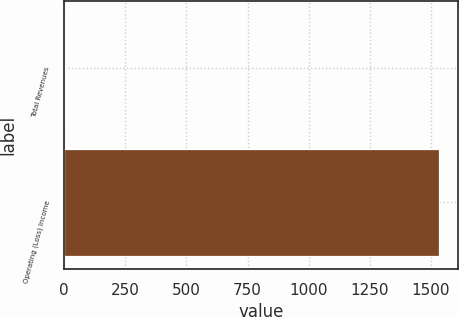Convert chart. <chart><loc_0><loc_0><loc_500><loc_500><bar_chart><fcel>Total Revenues<fcel>Operating (Loss) Income<nl><fcel>4<fcel>1532<nl></chart> 